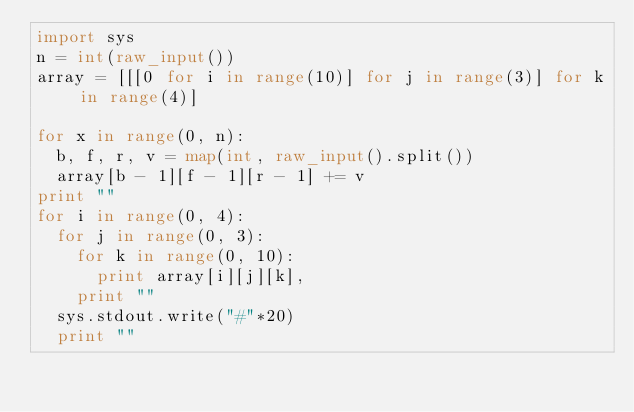<code> <loc_0><loc_0><loc_500><loc_500><_Python_>import sys
n = int(raw_input())
array = [[[0 for i in range(10)] for j in range(3)] for k in range(4)]

for x in range(0, n):
	b, f, r, v = map(int, raw_input().split())
	array[b - 1][f - 1][r - 1] += v
print ""
for i in range(0, 4):
	for j in range(0, 3):
		for k in range(0, 10):
			print array[i][j][k],
		print ""
	sys.stdout.write("#"*20)
	print ""</code> 